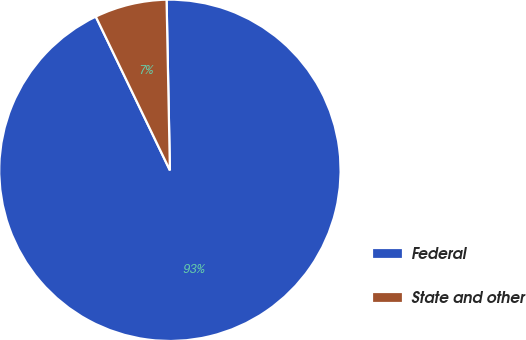Convert chart. <chart><loc_0><loc_0><loc_500><loc_500><pie_chart><fcel>Federal<fcel>State and other<nl><fcel>93.16%<fcel>6.84%<nl></chart> 